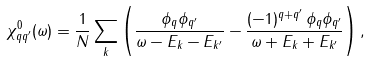Convert formula to latex. <formula><loc_0><loc_0><loc_500><loc_500>\chi _ { q q ^ { \prime } } ^ { 0 } ( \omega ) = \frac { 1 } { N } \sum _ { k } \left ( \frac { \phi _ { q } \phi _ { q ^ { \prime } } } { \omega - E _ { k } - E _ { k ^ { \prime } } } - \frac { ( - 1 ) ^ { q + q ^ { \prime } } \, \phi _ { q } \phi _ { q ^ { \prime } } } { \omega + E _ { k } + E _ { k ^ { \prime } } } \right ) ,</formula> 